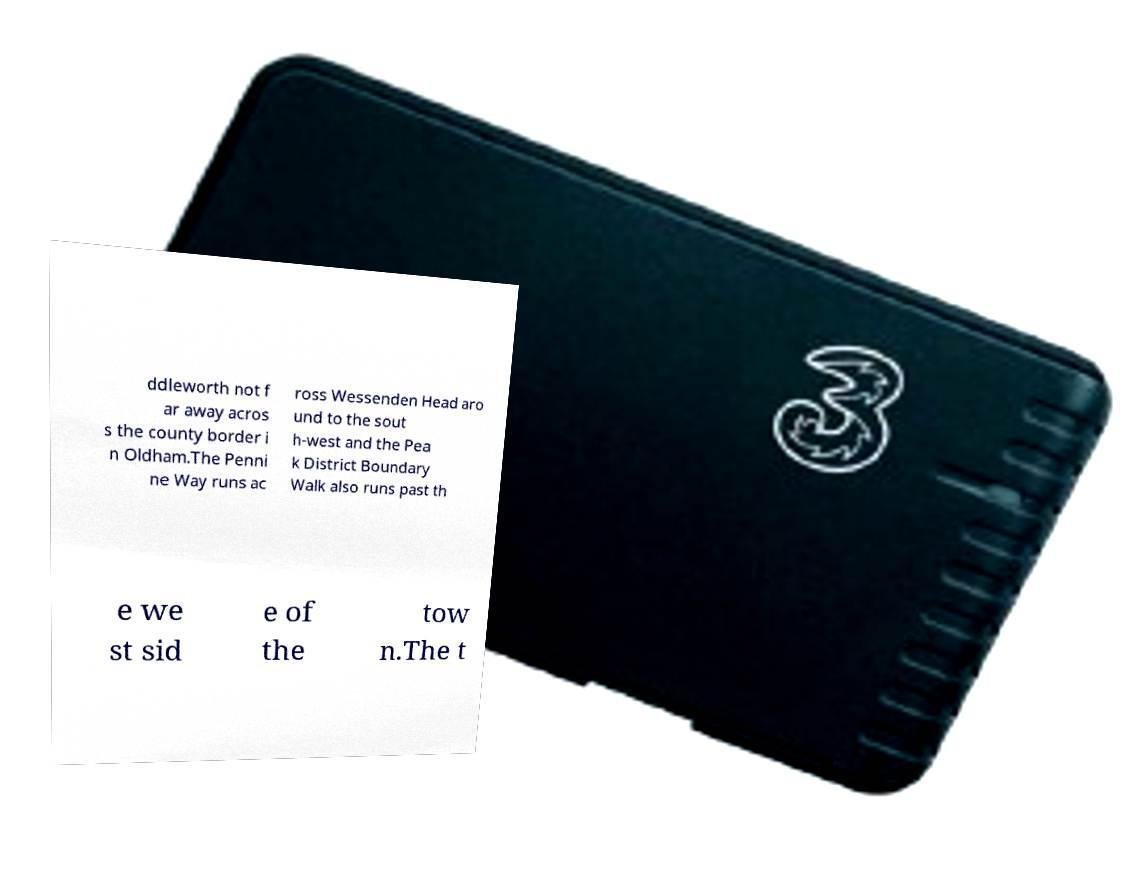Can you accurately transcribe the text from the provided image for me? ddleworth not f ar away acros s the county border i n Oldham.The Penni ne Way runs ac ross Wessenden Head aro und to the sout h-west and the Pea k District Boundary Walk also runs past th e we st sid e of the tow n.The t 